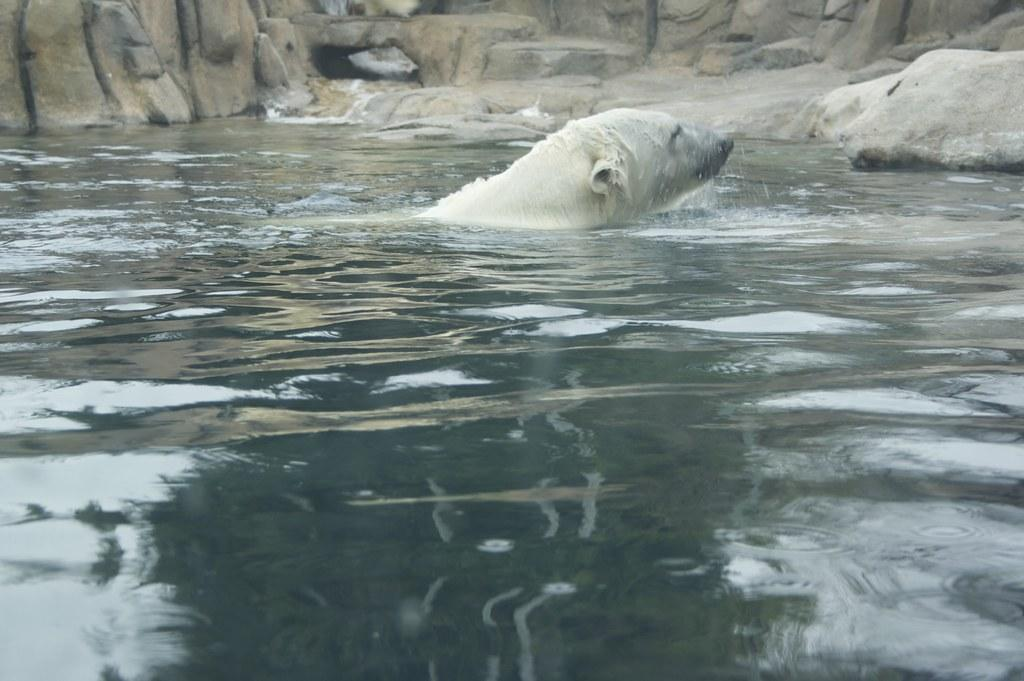What animal is in the water in the image? There is a polar bear in the water in the image. What can be seen in the background of the image? There appears to be a hill in the background. What is visible at the bottom of the image? There is water visible at the bottom of the image. What type of screw can be seen holding the gate in the image? There is no gate or screw present in the image; it features a polar bear in the water with a hill in the background. 